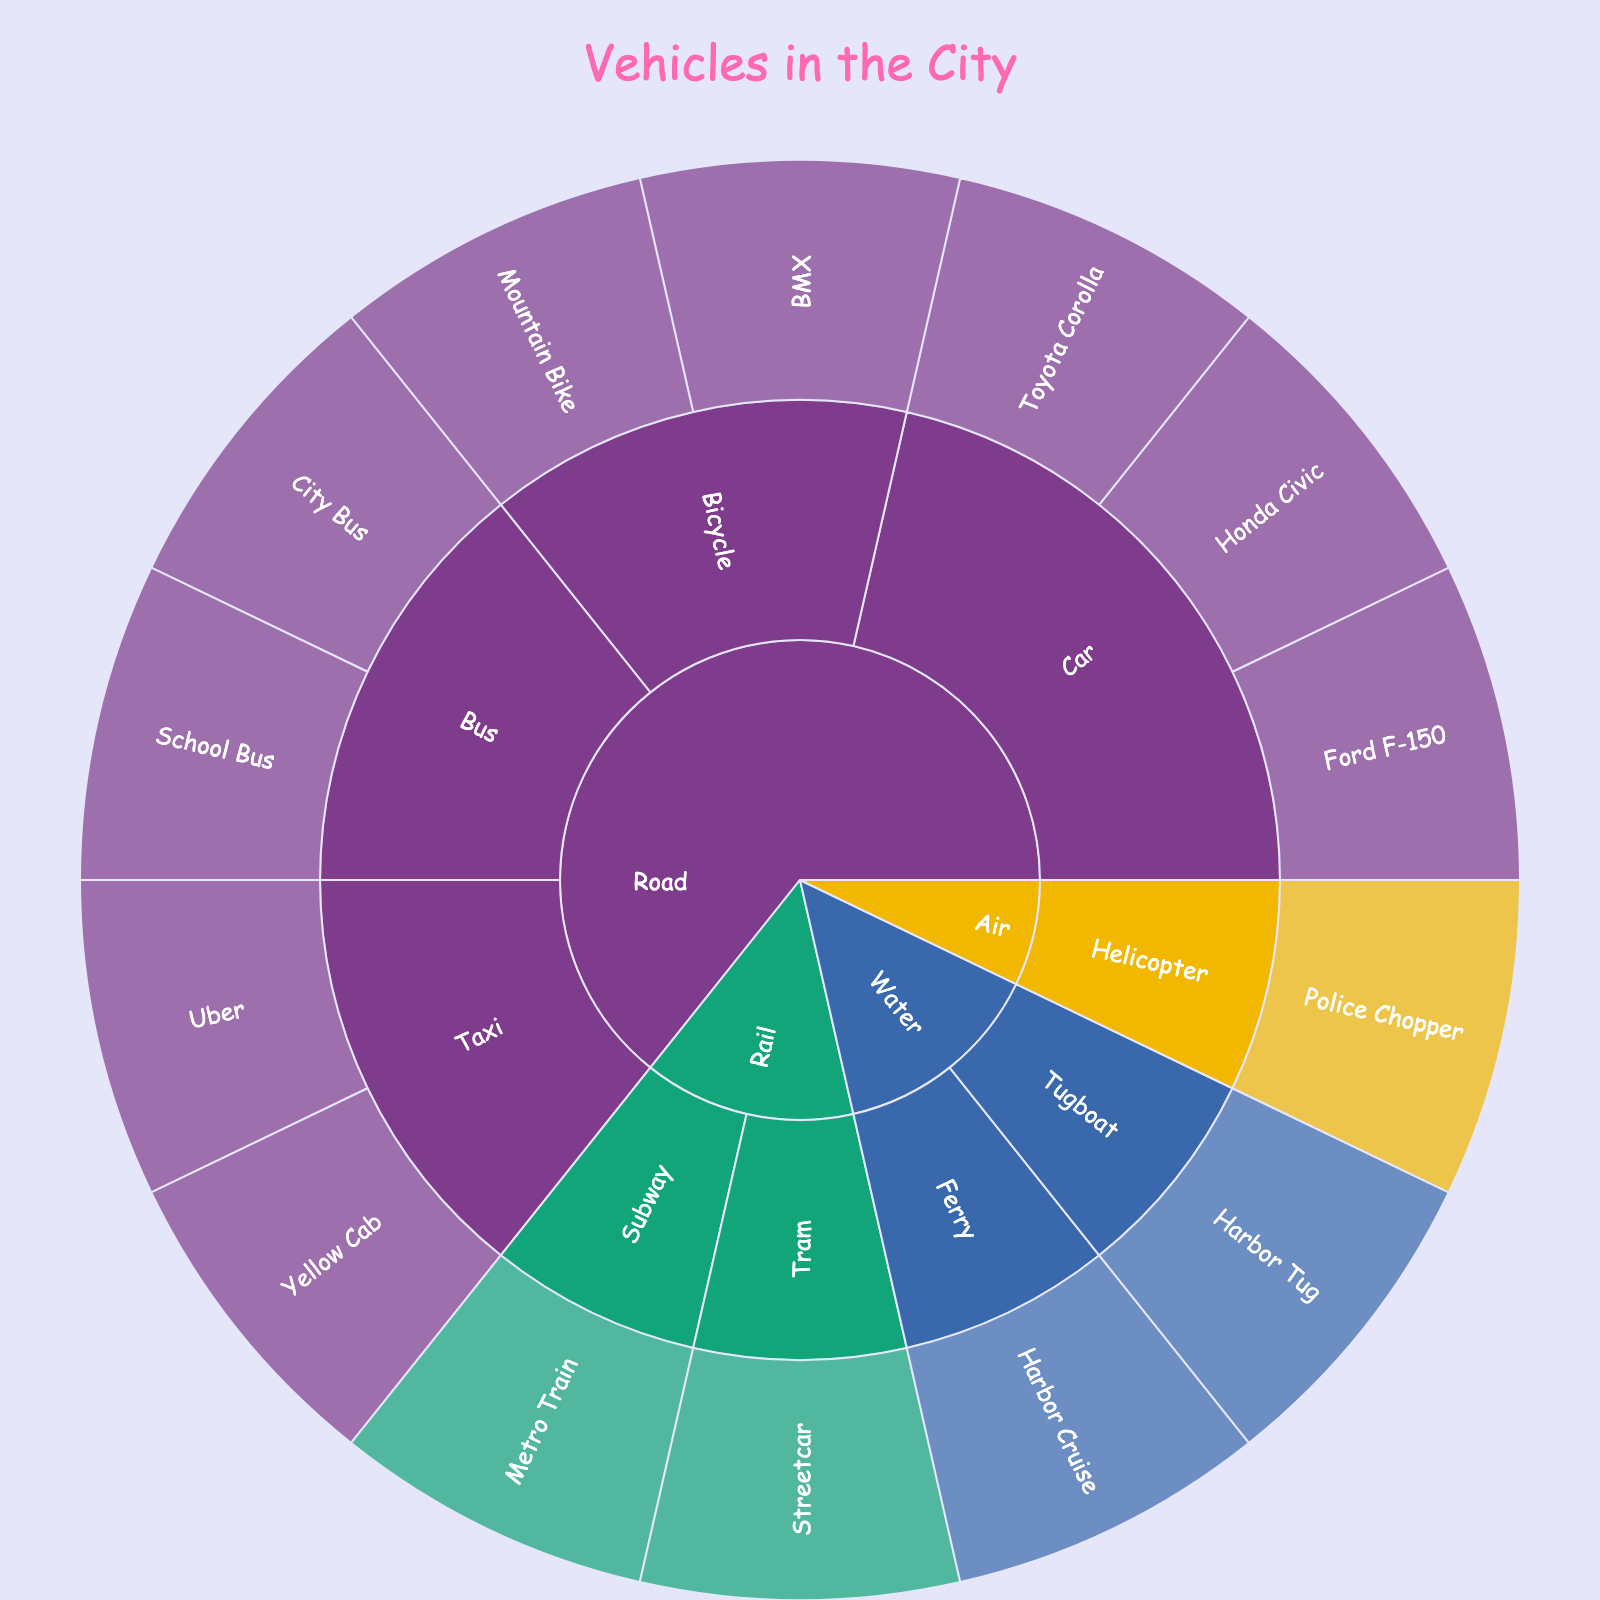What is the title of the figure? The title is usually at the top of the figure and provides a summary of what the figure is about. Here, the title reads "Vehicles in the City".
Answer: Vehicles in the City How many categories of vehicles can you see directly from the center of the plot? The center of the sunburst plot typically shows the highest-level categories. From the center, we can see 4 categories: Road, Rail, Air, and Water.
Answer: 4 What are the two types of buses shown in the plot? By looking under the "Road" category and then the "Bus" subcategory, we can see the two bus types listed: City Bus and School Bus.
Answer: City Bus and School Bus How many specific models are listed under the category "Road"? Under the "Road" category, we have Car (3 models), Bus (2 models), Taxi (2 models), and Bicycle (2 models). Adding them up, 3 + 2 + 2 + 2 = 9.
Answer: 9 Which mode of transportation has only one type listed under it? By observing the outermost layer of each major mode of transportation, "Air" only has one type, which is Helicopter.
Answer: Air How many types of cars are listed? If we look under the "Car" subcategory of "Road", we see three specific models listed: Toyota Corolla, Honda Civic, and Ford F-150.
Answer: 3 Are there more types of Taxis or Bicycles? By comparing the "Taxi" and "Bicycle" subcategories under "Road", each has 2 specific models, so they are equal.
Answer: Equal What types of transportation are categorized under "Water"? Looking under the "Water" category, we can see the types listed are Ferry and Tugboat.
Answer: Ferry and Tugboat Which mode of transportation includes a Police Chopper? Checking each mode of transportation for the specific model "Police Chopper", it is listed under "Air".
Answer: Air 